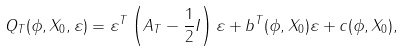<formula> <loc_0><loc_0><loc_500><loc_500>Q _ { T } ( \phi , X _ { 0 } , \varepsilon ) = \varepsilon ^ { T } \left ( A _ { T } - \frac { 1 } { 2 } I \right ) \varepsilon + b ^ { T } ( \phi , X _ { 0 } ) \varepsilon + c ( \phi , X _ { 0 } ) ,</formula> 